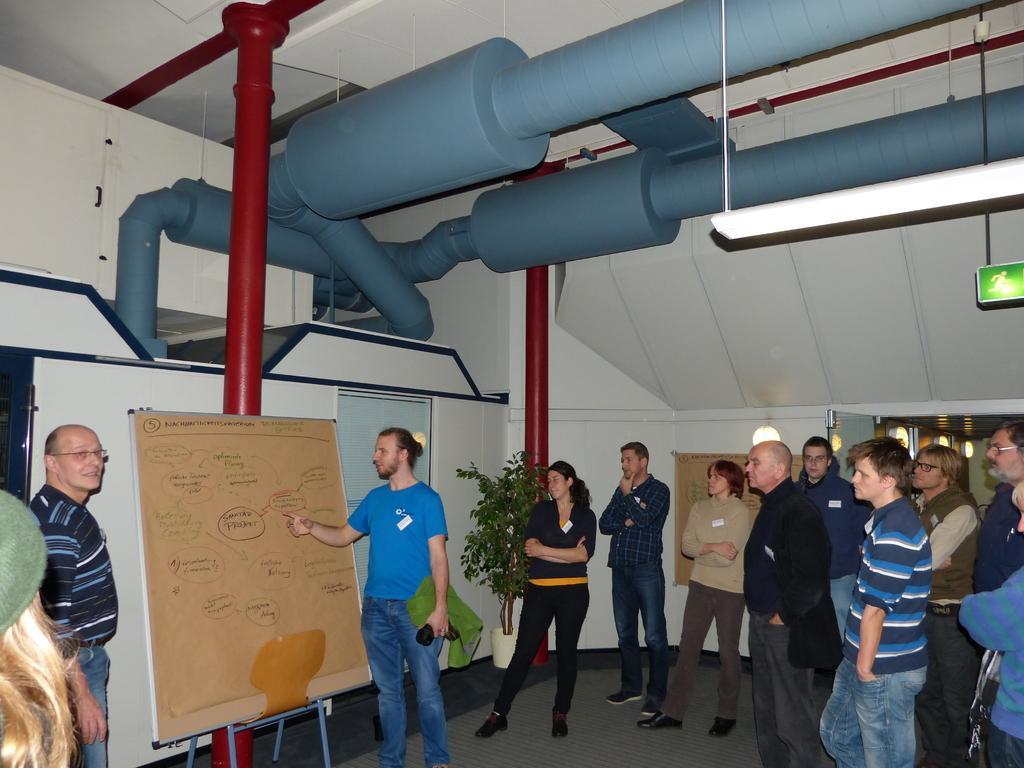In one or two sentences, can you explain what this image depicts? In this picture we can see a group of people standing on the floor and on the path there is a stand with a board. Behind the people there is a house plant, wall, sign board and some items. 